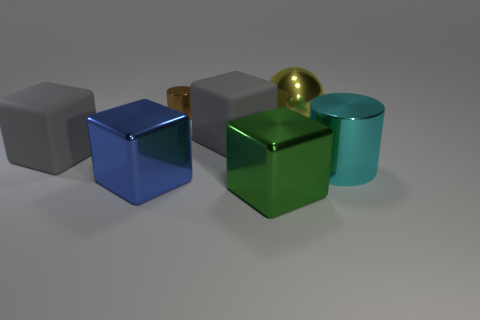There is a big matte object right of the blue metallic thing; what color is it?
Your answer should be compact. Gray. Do the large yellow metal thing and the small brown object have the same shape?
Keep it short and to the point. No. There is a large block that is both on the right side of the tiny shiny cylinder and behind the green metallic block; what is its color?
Provide a succinct answer. Gray. Does the metal object that is behind the large yellow thing have the same size as the gray object left of the brown metal cylinder?
Your answer should be compact. No. What number of objects are either large metallic objects behind the big cyan object or brown cylinders?
Keep it short and to the point. 2. What is the material of the large blue thing?
Give a very brief answer. Metal. Does the cyan shiny cylinder have the same size as the blue thing?
Ensure brevity in your answer.  Yes. How many blocks are either big shiny objects or gray objects?
Your answer should be very brief. 4. What color is the cylinder that is in front of the gray matte object on the left side of the large blue metal object?
Offer a very short reply. Cyan. Is the number of rubber objects that are in front of the green metal block less than the number of big blue things right of the large cyan cylinder?
Your response must be concise. No. 